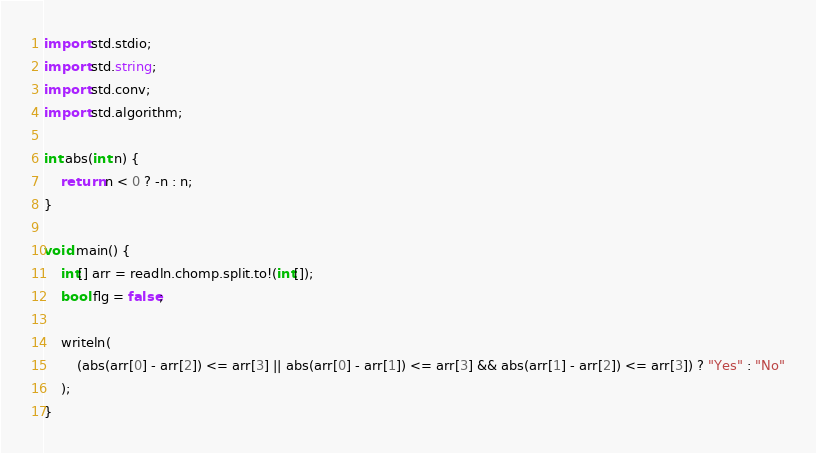<code> <loc_0><loc_0><loc_500><loc_500><_D_>import std.stdio;
import std.string;
import std.conv;
import std.algorithm;

int abs(int n) {
    return n < 0 ? -n : n;
}

void main() {
    int[] arr = readln.chomp.split.to!(int[]);
    bool flg = false;

    writeln(
        (abs(arr[0] - arr[2]) <= arr[3] || abs(arr[0] - arr[1]) <= arr[3] && abs(arr[1] - arr[2]) <= arr[3]) ? "Yes" : "No"
    );
}</code> 